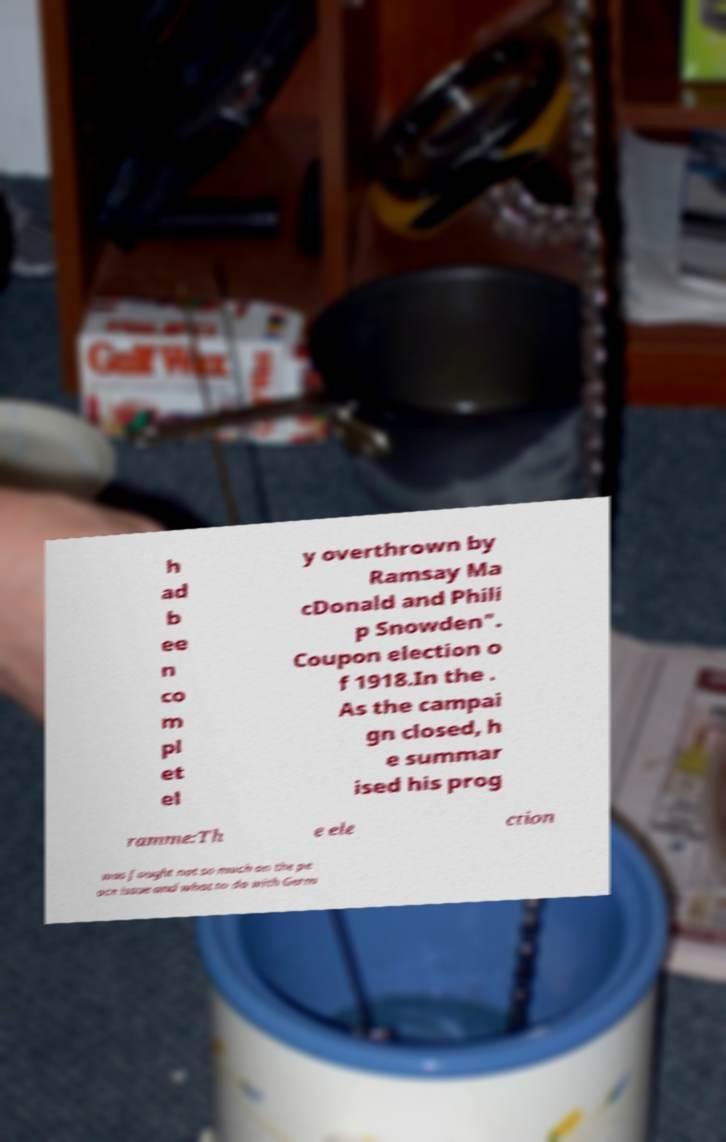What messages or text are displayed in this image? I need them in a readable, typed format. h ad b ee n co m pl et el y overthrown by Ramsay Ma cDonald and Phili p Snowden". Coupon election o f 1918.In the . As the campai gn closed, h e summar ised his prog ramme:Th e ele ction was fought not so much on the pe ace issue and what to do with Germ 